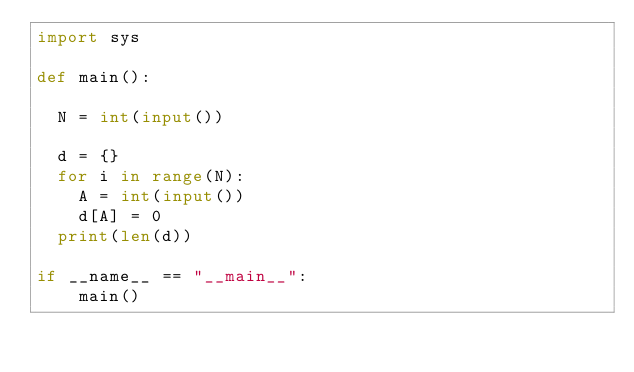<code> <loc_0><loc_0><loc_500><loc_500><_Python_>import sys

def main():

	N = int(input())
	
	d = {}
	for i in range(N):
		A = int(input())
		d[A] = 0
	print(len(d))
	
if __name__ == "__main__":
    main()</code> 